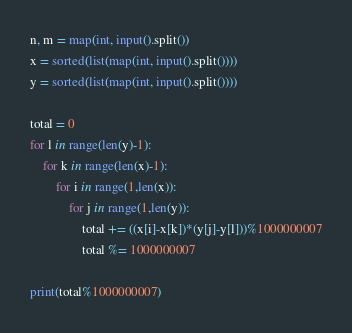Convert code to text. <code><loc_0><loc_0><loc_500><loc_500><_Python_>n, m = map(int, input().split())
x = sorted(list(map(int, input().split())))
y = sorted(list(map(int, input().split())))

total = 0
for l in range(len(y)-1):
	for k in range(len(x)-1):
		for i in range(1,len(x)):
			for j in range(1,len(y)):
				total += ((x[i]-x[k])*(y[j]-y[l]))%1000000007
				total %= 1000000007

print(total%1000000007)</code> 